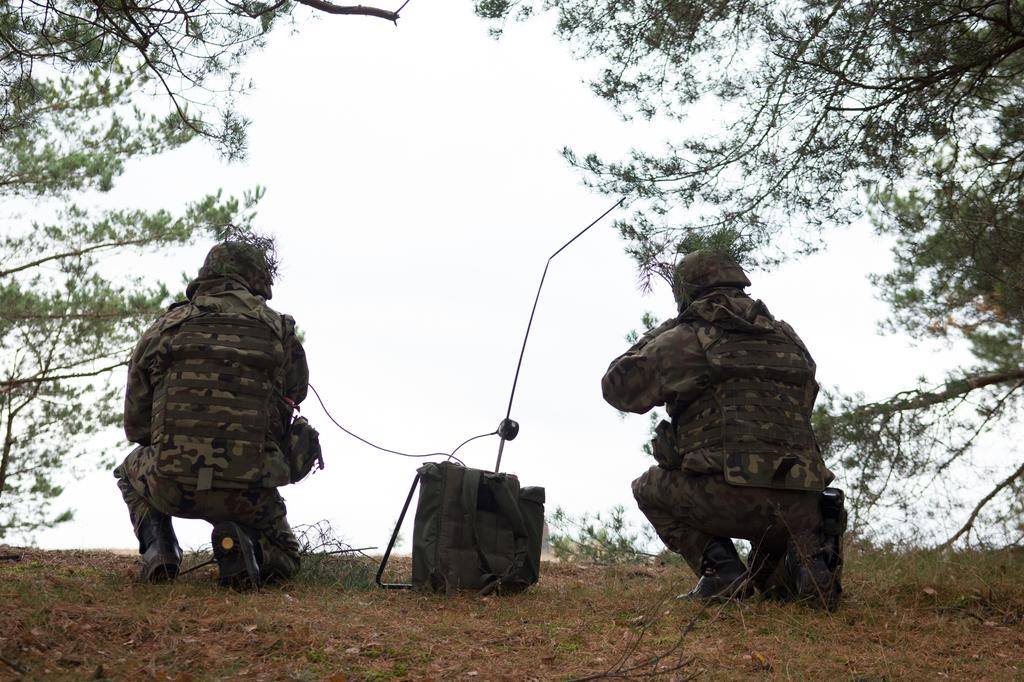How many soldiers are in the image? There are two soldiers in the image. What is located between the soldiers? There is a bag between the soldiers. What can be seen around the soldiers? There are branches of trees around the soldiers. How many icicles are hanging from the branches of trees in the image? There are no icicles visible in the image; only branches of trees are mentioned. 